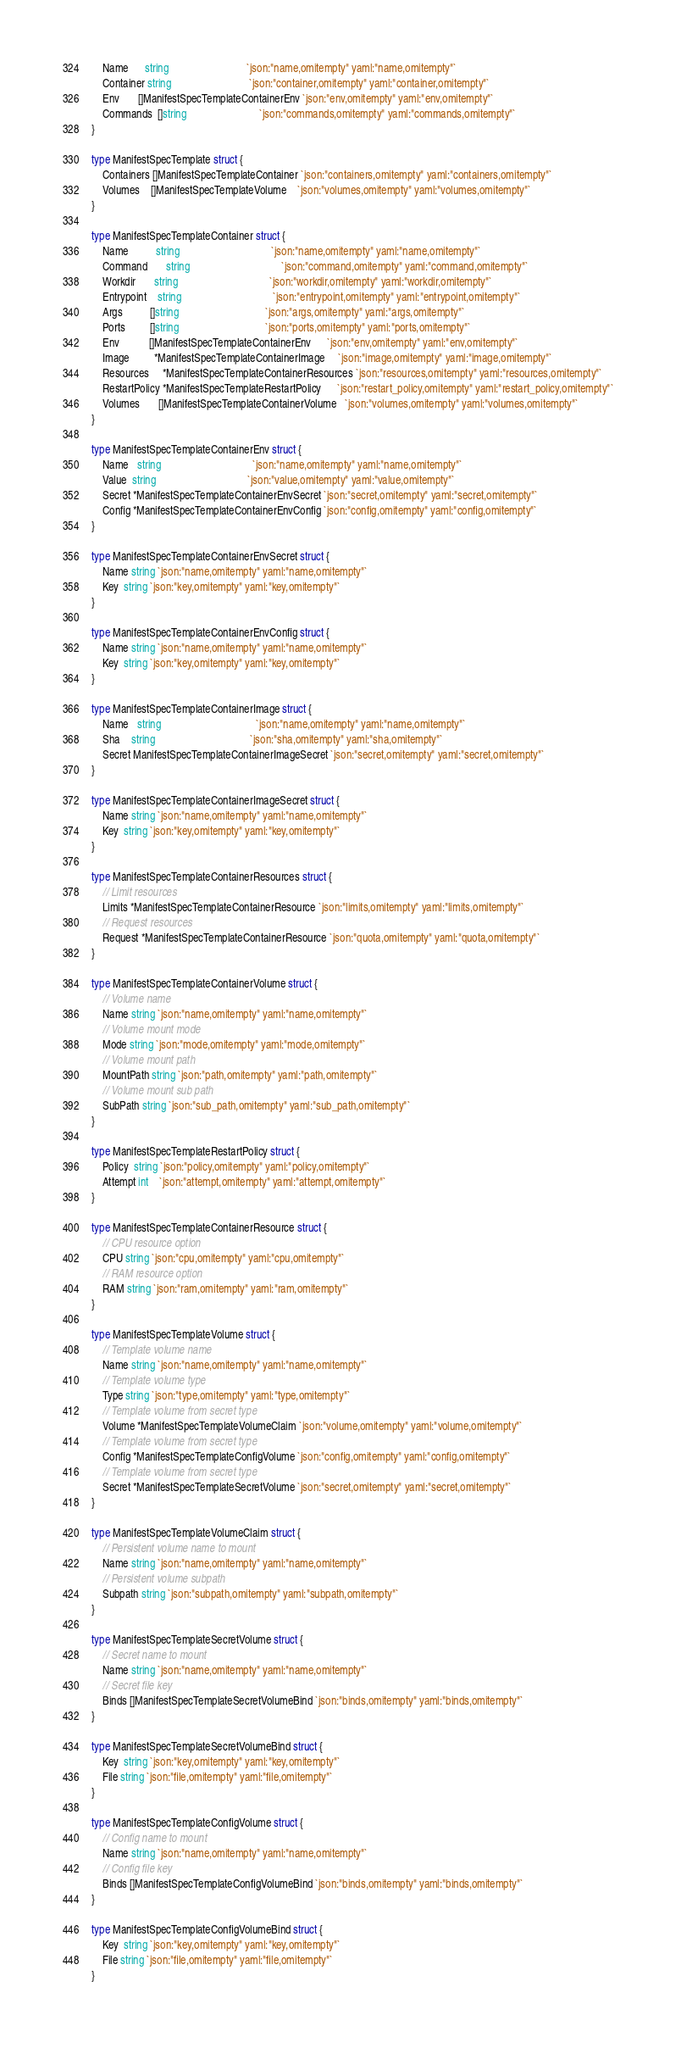Convert code to text. <code><loc_0><loc_0><loc_500><loc_500><_Go_>	Name      string                             `json:"name,omitempty" yaml:"name,omitempty"`
	Container string                             `json:"container,omitempty" yaml:"container,omitempty"`
	Env       []ManifestSpecTemplateContainerEnv `json:"env,omitempty" yaml:"env,omitempty"`
	Commands  []string                           `json:"commands,omitempty" yaml:"commands,omitempty"`
}

type ManifestSpecTemplate struct {
	Containers []ManifestSpecTemplateContainer `json:"containers,omitempty" yaml:"containers,omitempty"`
	Volumes    []ManifestSpecTemplateVolume    `json:"volumes,omitempty" yaml:"volumes,omitempty"`
}

type ManifestSpecTemplateContainer struct {
	Name          string                                  `json:"name,omitempty" yaml:"name,omitempty"`
	Command       string                                  `json:"command,omitempty" yaml:"command,omitempty"`
	Workdir       string                                  `json:"workdir,omitempty" yaml:"workdir,omitempty"`
	Entrypoint    string                                  `json:"entrypoint,omitempty" yaml:"entrypoint,omitempty"`
	Args          []string                                `json:"args,omitempty" yaml:"args,omitempty"`
	Ports         []string                                `json:"ports,omitempty" yaml:"ports,omitempty"`
	Env           []ManifestSpecTemplateContainerEnv      `json:"env,omitempty" yaml:"env,omitempty"`
	Image         *ManifestSpecTemplateContainerImage     `json:"image,omitempty" yaml:"image,omitempty"`
	Resources     *ManifestSpecTemplateContainerResources `json:"resources,omitempty" yaml:"resources,omitempty"`
	RestartPolicy *ManifestSpecTemplateRestartPolicy      `json:"restart_policy,omitempty" yaml:"restart_policy,omitempty"`
	Volumes       []ManifestSpecTemplateContainerVolume   `json:"volumes,omitempty" yaml:"volumes,omitempty"`
}

type ManifestSpecTemplateContainerEnv struct {
	Name   string                                  `json:"name,omitempty" yaml:"name,omitempty"`
	Value  string                                  `json:"value,omitempty" yaml:"value,omitempty"`
	Secret *ManifestSpecTemplateContainerEnvSecret `json:"secret,omitempty" yaml:"secret,omitempty"`
	Config *ManifestSpecTemplateContainerEnvConfig `json:"config,omitempty" yaml:"config,omitempty"`
}

type ManifestSpecTemplateContainerEnvSecret struct {
	Name string `json:"name,omitempty" yaml:"name,omitempty"`
	Key  string `json:"key,omitempty" yaml:"key,omitempty"`
}

type ManifestSpecTemplateContainerEnvConfig struct {
	Name string `json:"name,omitempty" yaml:"name,omitempty"`
	Key  string `json:"key,omitempty" yaml:"key,omitempty"`
}

type ManifestSpecTemplateContainerImage struct {
	Name   string                                   `json:"name,omitempty" yaml:"name,omitempty"`
	Sha    string                                   `json:"sha,omitempty" yaml:"sha,omitempty"`
	Secret ManifestSpecTemplateContainerImageSecret `json:"secret,omitempty" yaml:"secret,omitempty"`
}

type ManifestSpecTemplateContainerImageSecret struct {
	Name string `json:"name,omitempty" yaml:"name,omitempty"`
	Key  string `json:"key,omitempty" yaml:"key,omitempty"`
}

type ManifestSpecTemplateContainerResources struct {
	// Limit resources
	Limits *ManifestSpecTemplateContainerResource `json:"limits,omitempty" yaml:"limits,omitempty"`
	// Request resources
	Request *ManifestSpecTemplateContainerResource `json:"quota,omitempty" yaml:"quota,omitempty"`
}

type ManifestSpecTemplateContainerVolume struct {
	// Volume name
	Name string `json:"name,omitempty" yaml:"name,omitempty"`
	// Volume mount mode
	Mode string `json:"mode,omitempty" yaml:"mode,omitempty"`
	// Volume mount path
	MountPath string `json:"path,omitempty" yaml:"path,omitempty"`
	// Volume mount sub path
	SubPath string `json:"sub_path,omitempty" yaml:"sub_path,omitempty"`
}

type ManifestSpecTemplateRestartPolicy struct {
	Policy  string `json:"policy,omitempty" yaml:"policy,omitempty"`
	Attempt int    `json:"attempt,omitempty" yaml:"attempt,omitempty"`
}

type ManifestSpecTemplateContainerResource struct {
	// CPU resource option
	CPU string `json:"cpu,omitempty" yaml:"cpu,omitempty"`
	// RAM resource option
	RAM string `json:"ram,omitempty" yaml:"ram,omitempty"`
}

type ManifestSpecTemplateVolume struct {
	// Template volume name
	Name string `json:"name,omitempty" yaml:"name,omitempty"`
	// Template volume type
	Type string `json:"type,omitempty" yaml:"type,omitempty"`
	// Template volume from secret type
	Volume *ManifestSpecTemplateVolumeClaim `json:"volume,omitempty" yaml:"volume,omitempty"`
	// Template volume from secret type
	Config *ManifestSpecTemplateConfigVolume `json:"config,omitempty" yaml:"config,omitempty"`
	// Template volume from secret type
	Secret *ManifestSpecTemplateSecretVolume `json:"secret,omitempty" yaml:"secret,omitempty"`
}

type ManifestSpecTemplateVolumeClaim struct {
	// Persistent volume name to mount
	Name string `json:"name,omitempty" yaml:"name,omitempty"`
	// Persistent volume subpath
	Subpath string `json:"subpath,omitempty" yaml:"subpath,omitempty"`
}

type ManifestSpecTemplateSecretVolume struct {
	// Secret name to mount
	Name string `json:"name,omitempty" yaml:"name,omitempty"`
	// Secret file key
	Binds []ManifestSpecTemplateSecretVolumeBind `json:"binds,omitempty" yaml:"binds,omitempty"`
}

type ManifestSpecTemplateSecretVolumeBind struct {
	Key  string `json:"key,omitempty" yaml:"key,omitempty"`
	File string `json:"file,omitempty" yaml:"file,omitempty"`
}

type ManifestSpecTemplateConfigVolume struct {
	// Config name to mount
	Name string `json:"name,omitempty" yaml:"name,omitempty"`
	// Config file key
	Binds []ManifestSpecTemplateConfigVolumeBind `json:"binds,omitempty" yaml:"binds,omitempty"`
}

type ManifestSpecTemplateConfigVolumeBind struct {
	Key  string `json:"key,omitempty" yaml:"key,omitempty"`
	File string `json:"file,omitempty" yaml:"file,omitempty"`
}
</code> 